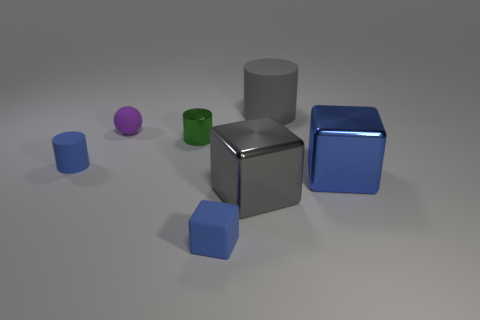Subtract all small cylinders. How many cylinders are left? 1 Subtract all gray cylinders. How many cylinders are left? 2 Add 2 large brown metal things. How many objects exist? 9 Subtract all cylinders. How many objects are left? 4 Subtract 2 cubes. How many cubes are left? 1 Subtract 0 cyan cylinders. How many objects are left? 7 Subtract all green cubes. Subtract all brown balls. How many cubes are left? 3 Subtract all blue cubes. How many green cylinders are left? 1 Subtract all gray matte things. Subtract all rubber cubes. How many objects are left? 5 Add 4 green metallic things. How many green metallic things are left? 5 